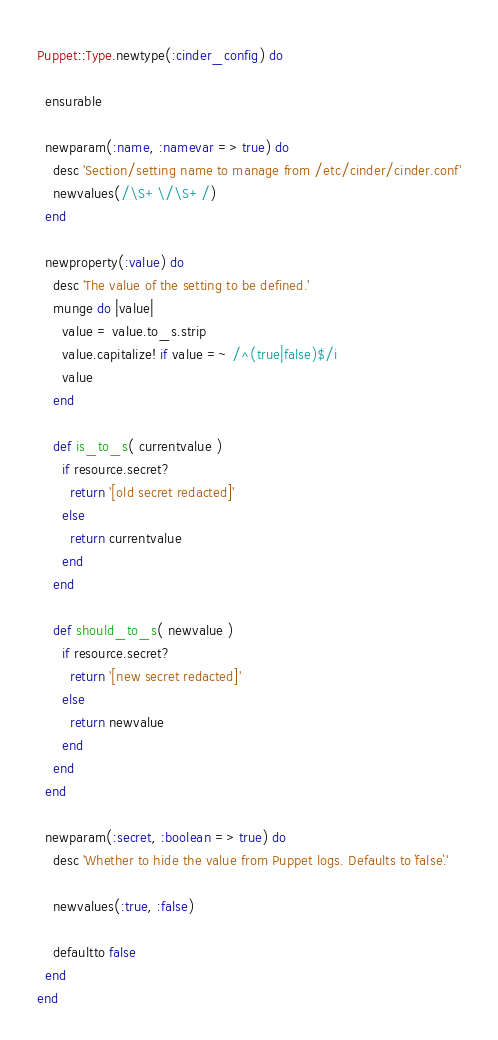Convert code to text. <code><loc_0><loc_0><loc_500><loc_500><_Ruby_>Puppet::Type.newtype(:cinder_config) do

  ensurable

  newparam(:name, :namevar => true) do
    desc 'Section/setting name to manage from /etc/cinder/cinder.conf'
    newvalues(/\S+\/\S+/)
  end

  newproperty(:value) do
    desc 'The value of the setting to be defined.'
    munge do |value|
      value = value.to_s.strip
      value.capitalize! if value =~ /^(true|false)$/i
      value
    end

    def is_to_s( currentvalue )
      if resource.secret?
        return '[old secret redacted]'
      else
        return currentvalue
      end
    end

    def should_to_s( newvalue )
      if resource.secret?
        return '[new secret redacted]'
      else
        return newvalue
      end
    end
  end

  newparam(:secret, :boolean => true) do
    desc 'Whether to hide the value from Puppet logs. Defaults to `false`.'

    newvalues(:true, :false)

    defaultto false
  end
end
</code> 